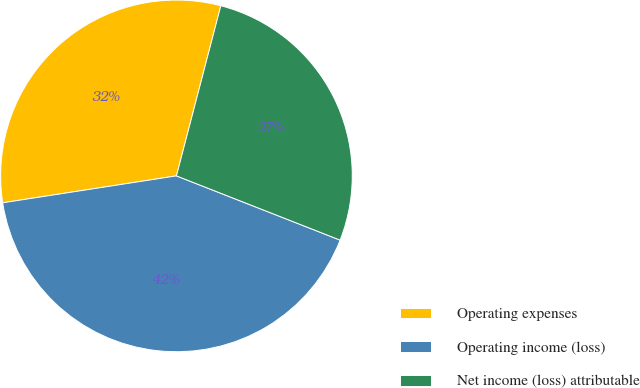Convert chart to OTSL. <chart><loc_0><loc_0><loc_500><loc_500><pie_chart><fcel>Operating expenses<fcel>Operating income (loss)<fcel>Net income (loss) attributable<nl><fcel>31.51%<fcel>41.6%<fcel>26.89%<nl></chart> 